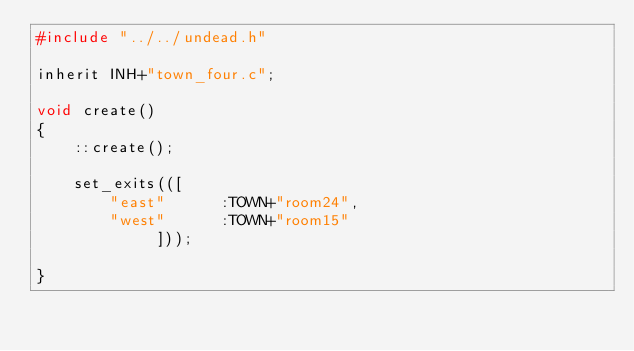Convert code to text. <code><loc_0><loc_0><loc_500><loc_500><_C_>#include "../../undead.h"

inherit INH+"town_four.c";

void create() 
{
    ::create();

    set_exits(([
        "east"      :TOWN+"room24",
        "west"      :TOWN+"room15"
             ]));

}
</code> 